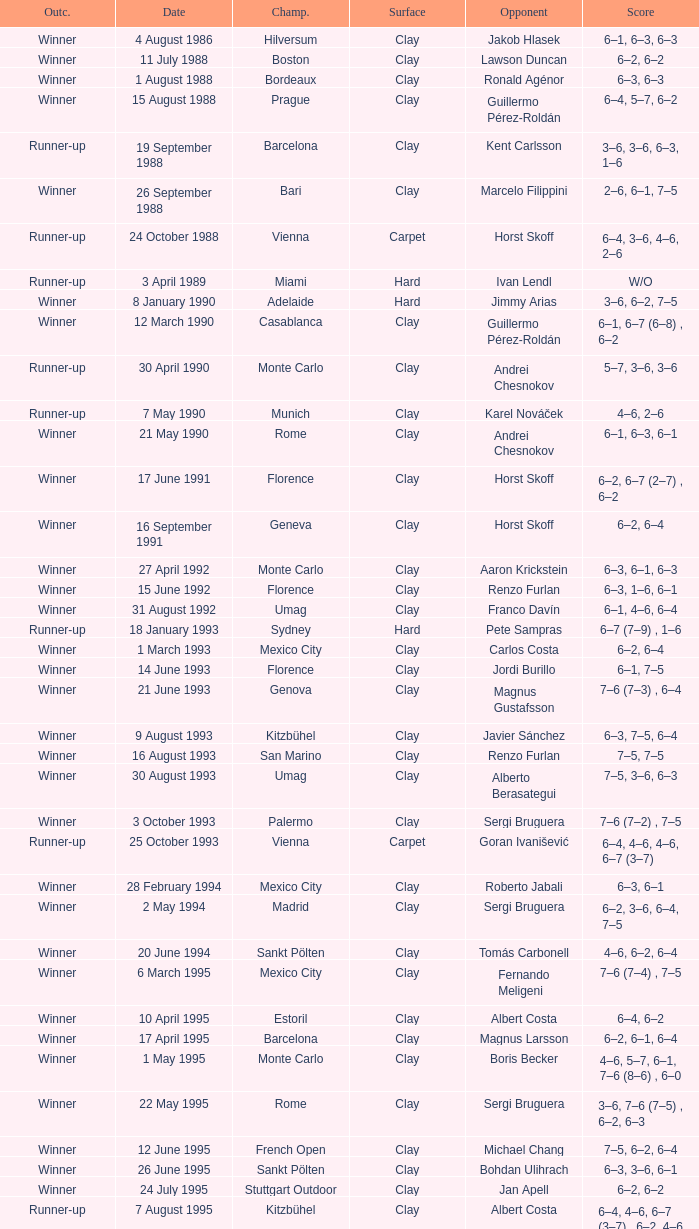What is the score when the outcome is winner against yevgeny kafelnikov? 6–2, 6–2, 6–4. Write the full table. {'header': ['Outc.', 'Date', 'Champ.', 'Surface', 'Opponent', 'Score'], 'rows': [['Winner', '4 August 1986', 'Hilversum', 'Clay', 'Jakob Hlasek', '6–1, 6–3, 6–3'], ['Winner', '11 July 1988', 'Boston', 'Clay', 'Lawson Duncan', '6–2, 6–2'], ['Winner', '1 August 1988', 'Bordeaux', 'Clay', 'Ronald Agénor', '6–3, 6–3'], ['Winner', '15 August 1988', 'Prague', 'Clay', 'Guillermo Pérez-Roldán', '6–4, 5–7, 6–2'], ['Runner-up', '19 September 1988', 'Barcelona', 'Clay', 'Kent Carlsson', '3–6, 3–6, 6–3, 1–6'], ['Winner', '26 September 1988', 'Bari', 'Clay', 'Marcelo Filippini', '2–6, 6–1, 7–5'], ['Runner-up', '24 October 1988', 'Vienna', 'Carpet', 'Horst Skoff', '6–4, 3–6, 4–6, 2–6'], ['Runner-up', '3 April 1989', 'Miami', 'Hard', 'Ivan Lendl', 'W/O'], ['Winner', '8 January 1990', 'Adelaide', 'Hard', 'Jimmy Arias', '3–6, 6–2, 7–5'], ['Winner', '12 March 1990', 'Casablanca', 'Clay', 'Guillermo Pérez-Roldán', '6–1, 6–7 (6–8) , 6–2'], ['Runner-up', '30 April 1990', 'Monte Carlo', 'Clay', 'Andrei Chesnokov', '5–7, 3–6, 3–6'], ['Runner-up', '7 May 1990', 'Munich', 'Clay', 'Karel Nováček', '4–6, 2–6'], ['Winner', '21 May 1990', 'Rome', 'Clay', 'Andrei Chesnokov', '6–1, 6–3, 6–1'], ['Winner', '17 June 1991', 'Florence', 'Clay', 'Horst Skoff', '6–2, 6–7 (2–7) , 6–2'], ['Winner', '16 September 1991', 'Geneva', 'Clay', 'Horst Skoff', '6–2, 6–4'], ['Winner', '27 April 1992', 'Monte Carlo', 'Clay', 'Aaron Krickstein', '6–3, 6–1, 6–3'], ['Winner', '15 June 1992', 'Florence', 'Clay', 'Renzo Furlan', '6–3, 1–6, 6–1'], ['Winner', '31 August 1992', 'Umag', 'Clay', 'Franco Davín', '6–1, 4–6, 6–4'], ['Runner-up', '18 January 1993', 'Sydney', 'Hard', 'Pete Sampras', '6–7 (7–9) , 1–6'], ['Winner', '1 March 1993', 'Mexico City', 'Clay', 'Carlos Costa', '6–2, 6–4'], ['Winner', '14 June 1993', 'Florence', 'Clay', 'Jordi Burillo', '6–1, 7–5'], ['Winner', '21 June 1993', 'Genova', 'Clay', 'Magnus Gustafsson', '7–6 (7–3) , 6–4'], ['Winner', '9 August 1993', 'Kitzbühel', 'Clay', 'Javier Sánchez', '6–3, 7–5, 6–4'], ['Winner', '16 August 1993', 'San Marino', 'Clay', 'Renzo Furlan', '7–5, 7–5'], ['Winner', '30 August 1993', 'Umag', 'Clay', 'Alberto Berasategui', '7–5, 3–6, 6–3'], ['Winner', '3 October 1993', 'Palermo', 'Clay', 'Sergi Bruguera', '7–6 (7–2) , 7–5'], ['Runner-up', '25 October 1993', 'Vienna', 'Carpet', 'Goran Ivanišević', '6–4, 4–6, 4–6, 6–7 (3–7)'], ['Winner', '28 February 1994', 'Mexico City', 'Clay', 'Roberto Jabali', '6–3, 6–1'], ['Winner', '2 May 1994', 'Madrid', 'Clay', 'Sergi Bruguera', '6–2, 3–6, 6–4, 7–5'], ['Winner', '20 June 1994', 'Sankt Pölten', 'Clay', 'Tomás Carbonell', '4–6, 6–2, 6–4'], ['Winner', '6 March 1995', 'Mexico City', 'Clay', 'Fernando Meligeni', '7–6 (7–4) , 7–5'], ['Winner', '10 April 1995', 'Estoril', 'Clay', 'Albert Costa', '6–4, 6–2'], ['Winner', '17 April 1995', 'Barcelona', 'Clay', 'Magnus Larsson', '6–2, 6–1, 6–4'], ['Winner', '1 May 1995', 'Monte Carlo', 'Clay', 'Boris Becker', '4–6, 5–7, 6–1, 7–6 (8–6) , 6–0'], ['Winner', '22 May 1995', 'Rome', 'Clay', 'Sergi Bruguera', '3–6, 7–6 (7–5) , 6–2, 6–3'], ['Winner', '12 June 1995', 'French Open', 'Clay', 'Michael Chang', '7–5, 6–2, 6–4'], ['Winner', '26 June 1995', 'Sankt Pölten', 'Clay', 'Bohdan Ulihrach', '6–3, 3–6, 6–1'], ['Winner', '24 July 1995', 'Stuttgart Outdoor', 'Clay', 'Jan Apell', '6–2, 6–2'], ['Runner-up', '7 August 1995', 'Kitzbühel', 'Clay', 'Albert Costa', '6–4, 4–6, 6–7 (3–7) , 6–2, 4–6'], ['Winner', '14 August 1995', 'San Marino', 'Clay', 'Andrea Gaudenzi', '6–2, 6–0'], ['Winner', '28 August 1995', 'Umag', 'Clay', 'Carlos Costa', '3–6, 7–6 (7–5) , 6–4'], ['Winner', '18 September 1995', 'Bucharest', 'Clay', 'Gilbert Schaller', '6–4, 6–3'], ['Runner-up', '23 October 1995', 'Vienna', 'Carpet', 'Filip Dewulf', '5–7, 2–6, 6–1, 5–7'], ['Winner', '30 October 1995', 'Essen', 'Carpet', 'MaliVai Washington', '7–6 (8–6) , 2–6, 6–3, 6–4'], ['Winner', '11 March 1996', 'Mexico City', 'Clay', 'Jiří Novák', '7–6 (7–3) , 6–2'], ['Winner', '15 April 1996', 'Estoril', 'Clay', 'Andrea Gaudenzi', '7–6 (7–4) , 6–4'], ['Winner', '22 April 1996', 'Barcelona', 'Clay', 'Marcelo Ríos', '6–3, 4–6, 6–4, 6–1'], ['Winner', '29 April 1996', 'Monte Carlo', 'Clay', 'Albert Costa', '6–3, 5–7, 4–6, 6–3, 6–2'], ['Winner', '20 May 1996', 'Rome', 'Clay', 'Richard Krajicek', '6–2, 6–4, 3–6, 6–3'], ['Winner', '22 July 1996', 'Stuttgart Outdoor', 'Clay', 'Yevgeny Kafelnikov', '6–2, 6–2, 6–4'], ['Winner', '16 September 1996', 'Bogotá', 'Clay', 'Nicolás Lapentti', '6–7 (6–8) , 6–2, 6–3'], ['Winner', '17 February 1997', 'Dubai', 'Hard', 'Goran Ivanišević', '7–5, 7–6 (7–3)'], ['Winner', '31 March 1997', 'Miami', 'Hard', 'Sergi Bruguera', '7–6 (8–6) , 6–3, 6–1'], ['Runner-up', '11 August 1997', 'Cincinnati', 'Hard', 'Pete Sampras', '3–6, 4–6'], ['Runner-up', '13 April 1998', 'Estoril', 'Clay', 'Alberto Berasategui', '6–3, 1–6, 3–6']]} 